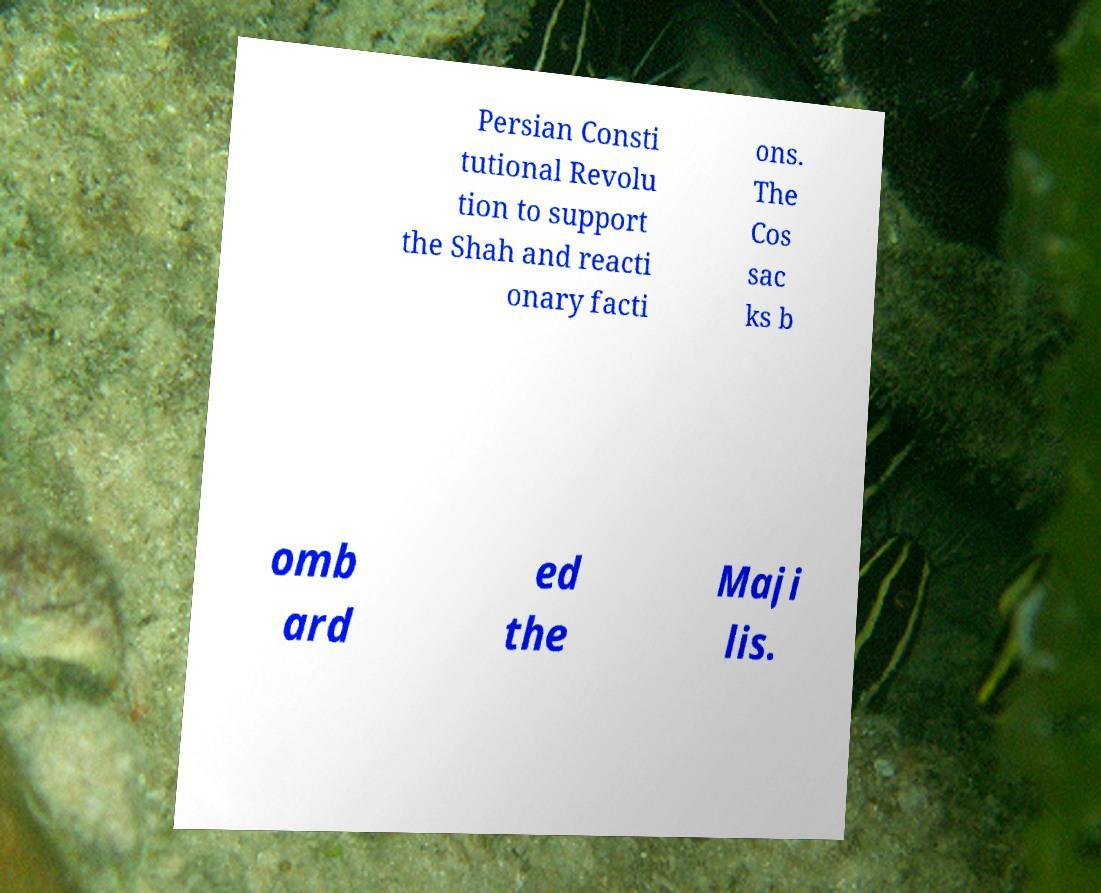Can you accurately transcribe the text from the provided image for me? Persian Consti tutional Revolu tion to support the Shah and reacti onary facti ons. The Cos sac ks b omb ard ed the Maji lis. 